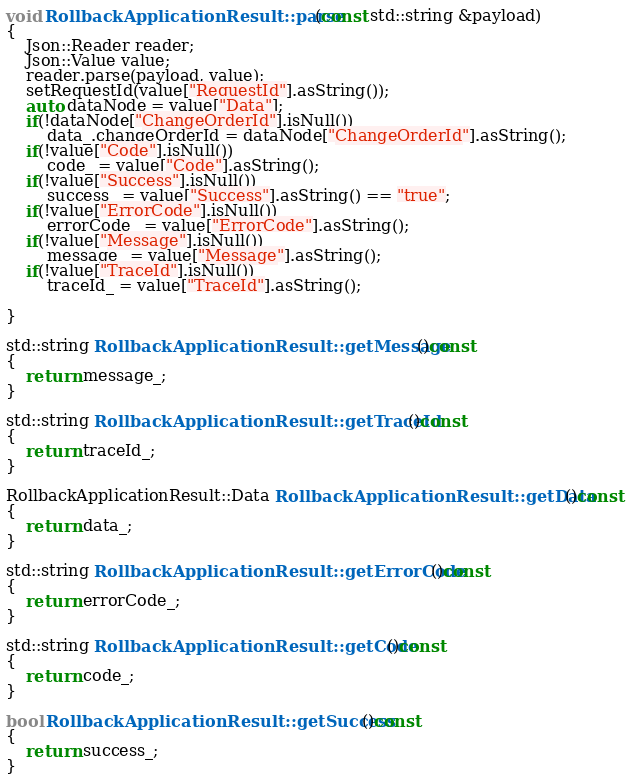Convert code to text. <code><loc_0><loc_0><loc_500><loc_500><_C++_>
void RollbackApplicationResult::parse(const std::string &payload)
{
	Json::Reader reader;
	Json::Value value;
	reader.parse(payload, value);
	setRequestId(value["RequestId"].asString());
	auto dataNode = value["Data"];
	if(!dataNode["ChangeOrderId"].isNull())
		data_.changeOrderId = dataNode["ChangeOrderId"].asString();
	if(!value["Code"].isNull())
		code_ = value["Code"].asString();
	if(!value["Success"].isNull())
		success_ = value["Success"].asString() == "true";
	if(!value["ErrorCode"].isNull())
		errorCode_ = value["ErrorCode"].asString();
	if(!value["Message"].isNull())
		message_ = value["Message"].asString();
	if(!value["TraceId"].isNull())
		traceId_ = value["TraceId"].asString();

}

std::string RollbackApplicationResult::getMessage()const
{
	return message_;
}

std::string RollbackApplicationResult::getTraceId()const
{
	return traceId_;
}

RollbackApplicationResult::Data RollbackApplicationResult::getData()const
{
	return data_;
}

std::string RollbackApplicationResult::getErrorCode()const
{
	return errorCode_;
}

std::string RollbackApplicationResult::getCode()const
{
	return code_;
}

bool RollbackApplicationResult::getSuccess()const
{
	return success_;
}

</code> 